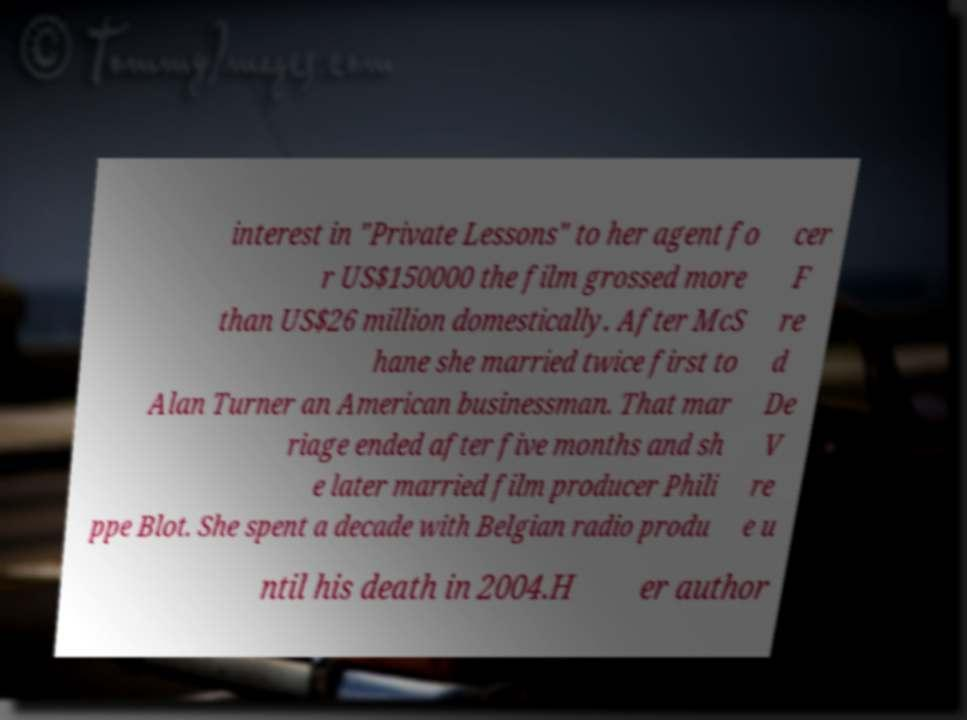What messages or text are displayed in this image? I need them in a readable, typed format. interest in "Private Lessons" to her agent fo r US$150000 the film grossed more than US$26 million domestically. After McS hane she married twice first to Alan Turner an American businessman. That mar riage ended after five months and sh e later married film producer Phili ppe Blot. She spent a decade with Belgian radio produ cer F re d De V re e u ntil his death in 2004.H er author 